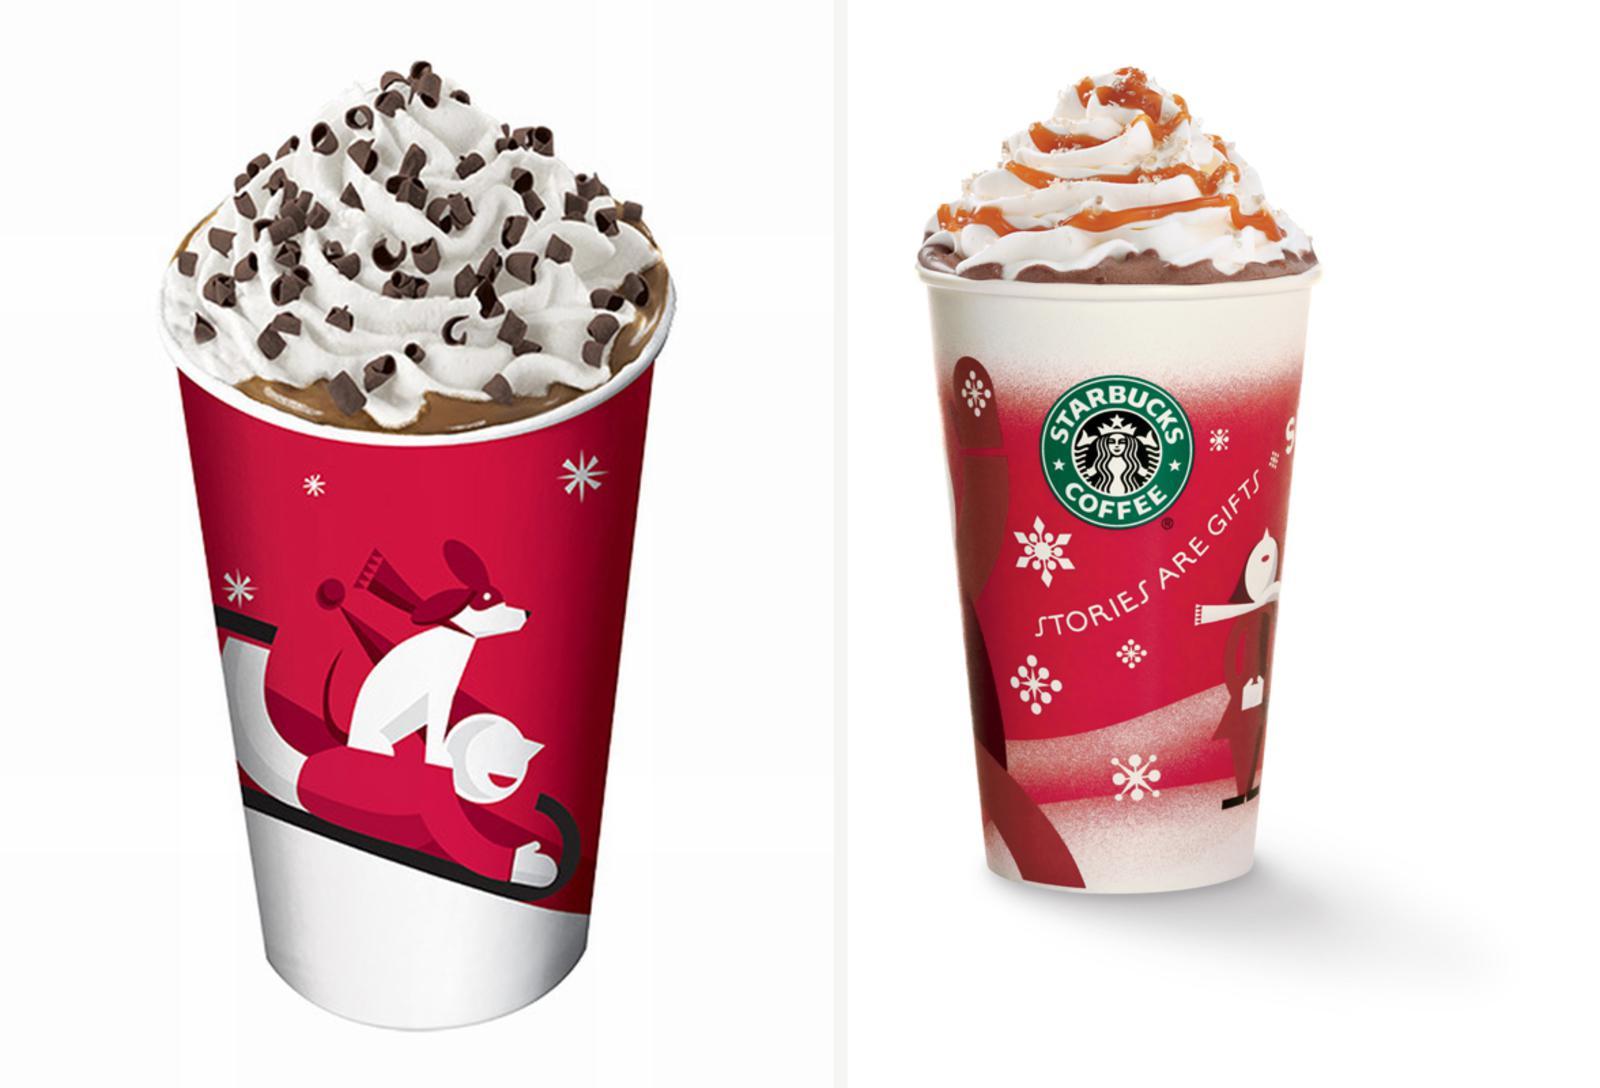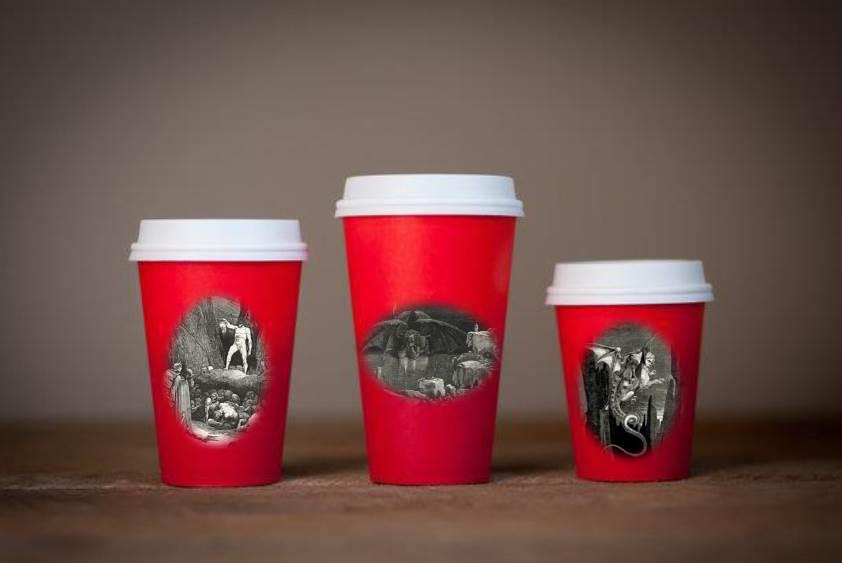The first image is the image on the left, the second image is the image on the right. Assess this claim about the two images: "There are exactly two cups.". Correct or not? Answer yes or no. No. 